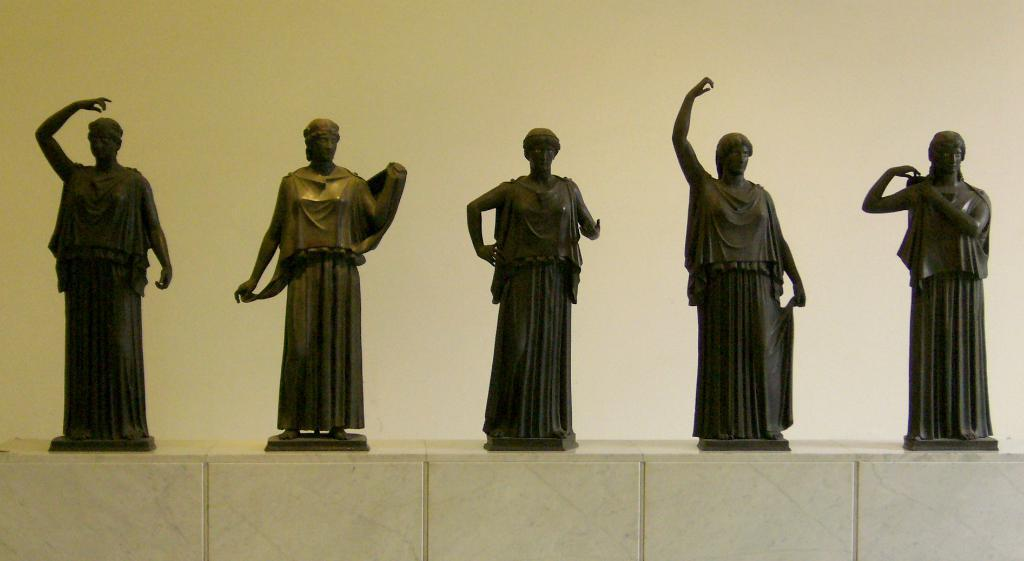What type of artwork can be seen in the image? There are sculptures in the image. Where are the sculptures located? The sculptures are on a surface. What can be seen behind the sculptures? There is a wall visible behind the sculptures. What type of leg can be seen on the sculptures in the image? There is no leg visible on the sculptures in the image, as they are not human or animal figures. 